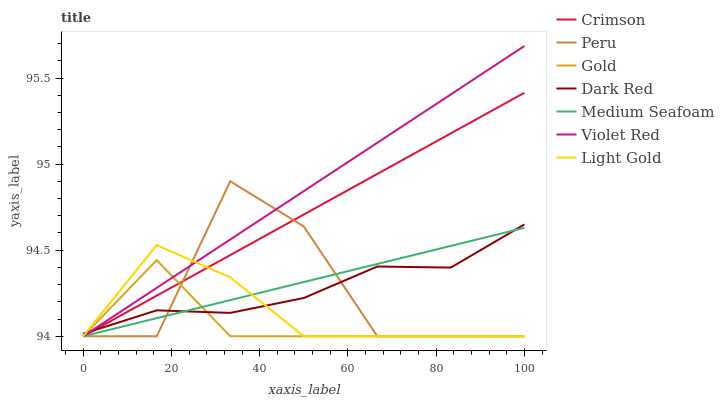Does Gold have the minimum area under the curve?
Answer yes or no. Yes. Does Violet Red have the maximum area under the curve?
Answer yes or no. Yes. Does Dark Red have the minimum area under the curve?
Answer yes or no. No. Does Dark Red have the maximum area under the curve?
Answer yes or no. No. Is Violet Red the smoothest?
Answer yes or no. Yes. Is Peru the roughest?
Answer yes or no. Yes. Is Gold the smoothest?
Answer yes or no. No. Is Gold the roughest?
Answer yes or no. No. Does Dark Red have the lowest value?
Answer yes or no. No. Does Dark Red have the highest value?
Answer yes or no. No. 